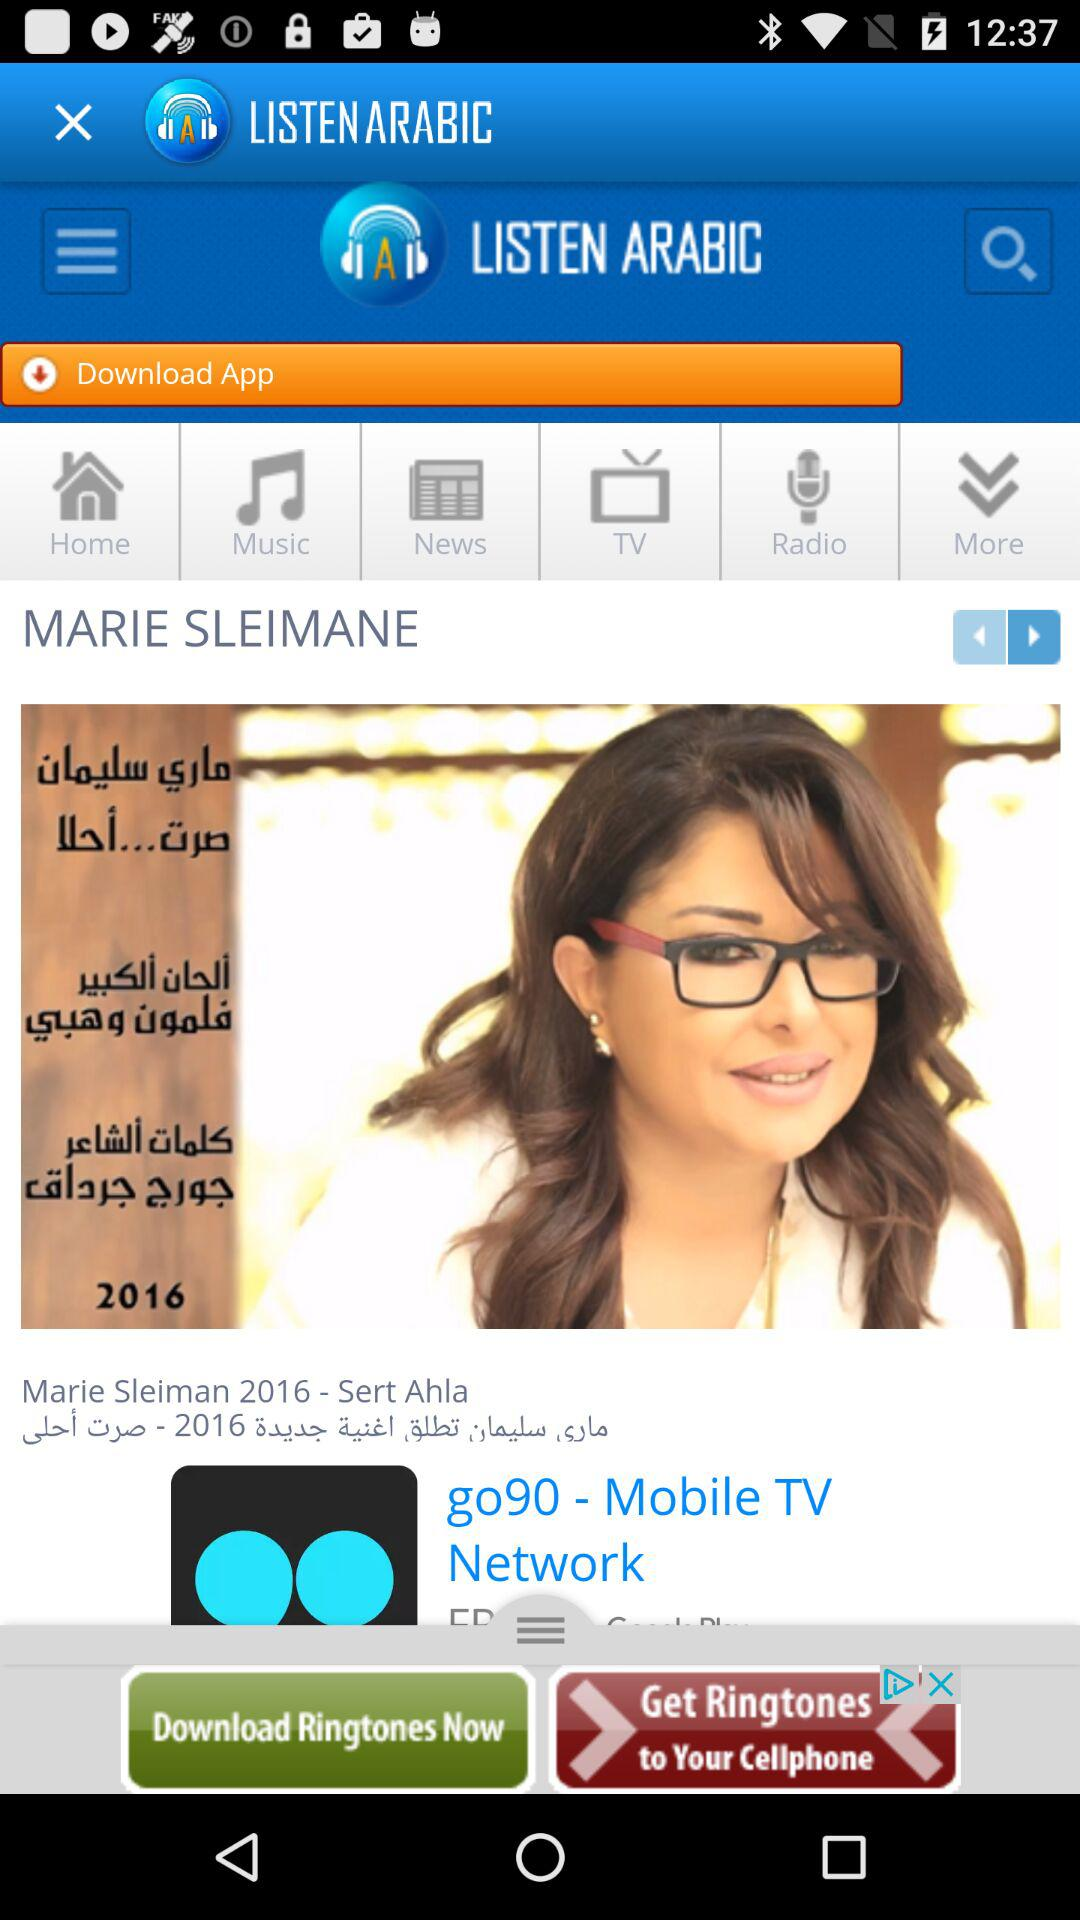What is the application name? The application name is "LISTEN ARABIC". 